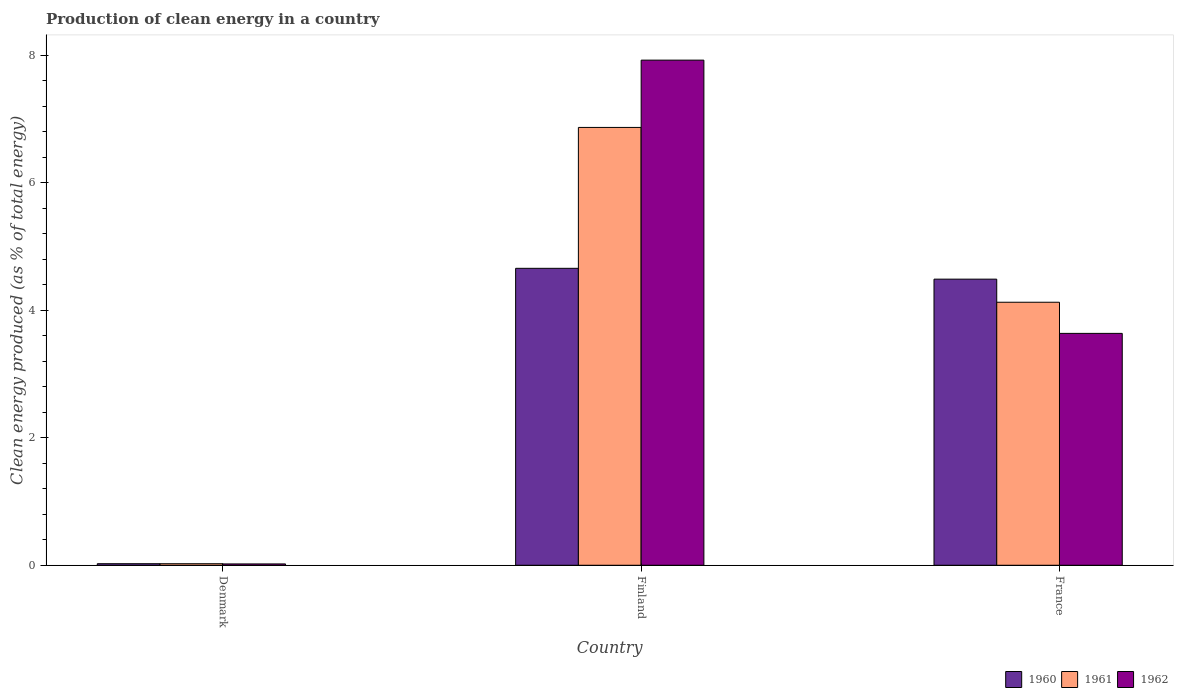Are the number of bars per tick equal to the number of legend labels?
Your answer should be compact. Yes. Are the number of bars on each tick of the X-axis equal?
Your answer should be very brief. Yes. How many bars are there on the 3rd tick from the right?
Offer a very short reply. 3. In how many cases, is the number of bars for a given country not equal to the number of legend labels?
Keep it short and to the point. 0. What is the percentage of clean energy produced in 1960 in France?
Offer a terse response. 4.49. Across all countries, what is the maximum percentage of clean energy produced in 1961?
Ensure brevity in your answer.  6.87. Across all countries, what is the minimum percentage of clean energy produced in 1962?
Ensure brevity in your answer.  0.02. In which country was the percentage of clean energy produced in 1961 maximum?
Offer a terse response. Finland. In which country was the percentage of clean energy produced in 1960 minimum?
Keep it short and to the point. Denmark. What is the total percentage of clean energy produced in 1960 in the graph?
Your response must be concise. 9.17. What is the difference between the percentage of clean energy produced in 1961 in Denmark and that in Finland?
Ensure brevity in your answer.  -6.84. What is the difference between the percentage of clean energy produced in 1962 in France and the percentage of clean energy produced in 1960 in Finland?
Offer a very short reply. -1.02. What is the average percentage of clean energy produced in 1960 per country?
Your answer should be compact. 3.06. What is the difference between the percentage of clean energy produced of/in 1962 and percentage of clean energy produced of/in 1960 in Denmark?
Your response must be concise. -0. In how many countries, is the percentage of clean energy produced in 1962 greater than 6.4 %?
Keep it short and to the point. 1. What is the ratio of the percentage of clean energy produced in 1961 in Denmark to that in France?
Ensure brevity in your answer.  0.01. Is the percentage of clean energy produced in 1961 in Finland less than that in France?
Provide a short and direct response. No. Is the difference between the percentage of clean energy produced in 1962 in Finland and France greater than the difference between the percentage of clean energy produced in 1960 in Finland and France?
Ensure brevity in your answer.  Yes. What is the difference between the highest and the second highest percentage of clean energy produced in 1960?
Your answer should be compact. -4.63. What is the difference between the highest and the lowest percentage of clean energy produced in 1961?
Provide a short and direct response. 6.84. In how many countries, is the percentage of clean energy produced in 1962 greater than the average percentage of clean energy produced in 1962 taken over all countries?
Keep it short and to the point. 1. Is the sum of the percentage of clean energy produced in 1960 in Denmark and France greater than the maximum percentage of clean energy produced in 1961 across all countries?
Offer a terse response. No. What does the 1st bar from the right in Denmark represents?
Your answer should be compact. 1962. Is it the case that in every country, the sum of the percentage of clean energy produced in 1961 and percentage of clean energy produced in 1962 is greater than the percentage of clean energy produced in 1960?
Give a very brief answer. Yes. Are all the bars in the graph horizontal?
Ensure brevity in your answer.  No. Does the graph contain any zero values?
Make the answer very short. No. How many legend labels are there?
Keep it short and to the point. 3. How are the legend labels stacked?
Your response must be concise. Horizontal. What is the title of the graph?
Ensure brevity in your answer.  Production of clean energy in a country. Does "1980" appear as one of the legend labels in the graph?
Provide a short and direct response. No. What is the label or title of the Y-axis?
Your answer should be very brief. Clean energy produced (as % of total energy). What is the Clean energy produced (as % of total energy) of 1960 in Denmark?
Provide a short and direct response. 0.02. What is the Clean energy produced (as % of total energy) of 1961 in Denmark?
Your response must be concise. 0.02. What is the Clean energy produced (as % of total energy) in 1962 in Denmark?
Provide a succinct answer. 0.02. What is the Clean energy produced (as % of total energy) of 1960 in Finland?
Your answer should be compact. 4.66. What is the Clean energy produced (as % of total energy) in 1961 in Finland?
Offer a very short reply. 6.87. What is the Clean energy produced (as % of total energy) in 1962 in Finland?
Ensure brevity in your answer.  7.92. What is the Clean energy produced (as % of total energy) of 1960 in France?
Give a very brief answer. 4.49. What is the Clean energy produced (as % of total energy) in 1961 in France?
Your response must be concise. 4.12. What is the Clean energy produced (as % of total energy) of 1962 in France?
Provide a succinct answer. 3.64. Across all countries, what is the maximum Clean energy produced (as % of total energy) of 1960?
Make the answer very short. 4.66. Across all countries, what is the maximum Clean energy produced (as % of total energy) of 1961?
Keep it short and to the point. 6.87. Across all countries, what is the maximum Clean energy produced (as % of total energy) of 1962?
Offer a terse response. 7.92. Across all countries, what is the minimum Clean energy produced (as % of total energy) of 1960?
Your response must be concise. 0.02. Across all countries, what is the minimum Clean energy produced (as % of total energy) in 1961?
Offer a very short reply. 0.02. Across all countries, what is the minimum Clean energy produced (as % of total energy) of 1962?
Offer a terse response. 0.02. What is the total Clean energy produced (as % of total energy) of 1960 in the graph?
Give a very brief answer. 9.17. What is the total Clean energy produced (as % of total energy) in 1961 in the graph?
Provide a succinct answer. 11.01. What is the total Clean energy produced (as % of total energy) in 1962 in the graph?
Offer a very short reply. 11.58. What is the difference between the Clean energy produced (as % of total energy) of 1960 in Denmark and that in Finland?
Keep it short and to the point. -4.63. What is the difference between the Clean energy produced (as % of total energy) in 1961 in Denmark and that in Finland?
Provide a short and direct response. -6.84. What is the difference between the Clean energy produced (as % of total energy) in 1962 in Denmark and that in Finland?
Provide a short and direct response. -7.9. What is the difference between the Clean energy produced (as % of total energy) of 1960 in Denmark and that in France?
Give a very brief answer. -4.46. What is the difference between the Clean energy produced (as % of total energy) of 1961 in Denmark and that in France?
Provide a succinct answer. -4.1. What is the difference between the Clean energy produced (as % of total energy) in 1962 in Denmark and that in France?
Make the answer very short. -3.62. What is the difference between the Clean energy produced (as % of total energy) in 1960 in Finland and that in France?
Your answer should be compact. 0.17. What is the difference between the Clean energy produced (as % of total energy) in 1961 in Finland and that in France?
Your answer should be compact. 2.74. What is the difference between the Clean energy produced (as % of total energy) of 1962 in Finland and that in France?
Keep it short and to the point. 4.28. What is the difference between the Clean energy produced (as % of total energy) in 1960 in Denmark and the Clean energy produced (as % of total energy) in 1961 in Finland?
Make the answer very short. -6.84. What is the difference between the Clean energy produced (as % of total energy) in 1960 in Denmark and the Clean energy produced (as % of total energy) in 1962 in Finland?
Make the answer very short. -7.9. What is the difference between the Clean energy produced (as % of total energy) in 1961 in Denmark and the Clean energy produced (as % of total energy) in 1962 in Finland?
Your answer should be very brief. -7.9. What is the difference between the Clean energy produced (as % of total energy) of 1960 in Denmark and the Clean energy produced (as % of total energy) of 1961 in France?
Give a very brief answer. -4.1. What is the difference between the Clean energy produced (as % of total energy) of 1960 in Denmark and the Clean energy produced (as % of total energy) of 1962 in France?
Keep it short and to the point. -3.61. What is the difference between the Clean energy produced (as % of total energy) in 1961 in Denmark and the Clean energy produced (as % of total energy) in 1962 in France?
Your answer should be compact. -3.61. What is the difference between the Clean energy produced (as % of total energy) of 1960 in Finland and the Clean energy produced (as % of total energy) of 1961 in France?
Offer a very short reply. 0.53. What is the difference between the Clean energy produced (as % of total energy) of 1960 in Finland and the Clean energy produced (as % of total energy) of 1962 in France?
Make the answer very short. 1.02. What is the difference between the Clean energy produced (as % of total energy) in 1961 in Finland and the Clean energy produced (as % of total energy) in 1962 in France?
Ensure brevity in your answer.  3.23. What is the average Clean energy produced (as % of total energy) in 1960 per country?
Keep it short and to the point. 3.06. What is the average Clean energy produced (as % of total energy) in 1961 per country?
Give a very brief answer. 3.67. What is the average Clean energy produced (as % of total energy) in 1962 per country?
Provide a short and direct response. 3.86. What is the difference between the Clean energy produced (as % of total energy) in 1960 and Clean energy produced (as % of total energy) in 1961 in Denmark?
Your answer should be compact. 0. What is the difference between the Clean energy produced (as % of total energy) of 1960 and Clean energy produced (as % of total energy) of 1962 in Denmark?
Keep it short and to the point. 0. What is the difference between the Clean energy produced (as % of total energy) in 1961 and Clean energy produced (as % of total energy) in 1962 in Denmark?
Keep it short and to the point. 0. What is the difference between the Clean energy produced (as % of total energy) of 1960 and Clean energy produced (as % of total energy) of 1961 in Finland?
Offer a terse response. -2.21. What is the difference between the Clean energy produced (as % of total energy) of 1960 and Clean energy produced (as % of total energy) of 1962 in Finland?
Give a very brief answer. -3.26. What is the difference between the Clean energy produced (as % of total energy) in 1961 and Clean energy produced (as % of total energy) in 1962 in Finland?
Offer a terse response. -1.06. What is the difference between the Clean energy produced (as % of total energy) in 1960 and Clean energy produced (as % of total energy) in 1961 in France?
Keep it short and to the point. 0.36. What is the difference between the Clean energy produced (as % of total energy) in 1960 and Clean energy produced (as % of total energy) in 1962 in France?
Your answer should be very brief. 0.85. What is the difference between the Clean energy produced (as % of total energy) in 1961 and Clean energy produced (as % of total energy) in 1962 in France?
Give a very brief answer. 0.49. What is the ratio of the Clean energy produced (as % of total energy) of 1960 in Denmark to that in Finland?
Ensure brevity in your answer.  0.01. What is the ratio of the Clean energy produced (as % of total energy) of 1961 in Denmark to that in Finland?
Your answer should be compact. 0. What is the ratio of the Clean energy produced (as % of total energy) in 1962 in Denmark to that in Finland?
Provide a short and direct response. 0. What is the ratio of the Clean energy produced (as % of total energy) of 1960 in Denmark to that in France?
Give a very brief answer. 0.01. What is the ratio of the Clean energy produced (as % of total energy) of 1961 in Denmark to that in France?
Your answer should be compact. 0.01. What is the ratio of the Clean energy produced (as % of total energy) in 1962 in Denmark to that in France?
Provide a short and direct response. 0.01. What is the ratio of the Clean energy produced (as % of total energy) in 1960 in Finland to that in France?
Offer a very short reply. 1.04. What is the ratio of the Clean energy produced (as % of total energy) in 1961 in Finland to that in France?
Make the answer very short. 1.66. What is the ratio of the Clean energy produced (as % of total energy) in 1962 in Finland to that in France?
Your response must be concise. 2.18. What is the difference between the highest and the second highest Clean energy produced (as % of total energy) of 1960?
Offer a very short reply. 0.17. What is the difference between the highest and the second highest Clean energy produced (as % of total energy) of 1961?
Make the answer very short. 2.74. What is the difference between the highest and the second highest Clean energy produced (as % of total energy) of 1962?
Keep it short and to the point. 4.28. What is the difference between the highest and the lowest Clean energy produced (as % of total energy) of 1960?
Your response must be concise. 4.63. What is the difference between the highest and the lowest Clean energy produced (as % of total energy) of 1961?
Make the answer very short. 6.84. What is the difference between the highest and the lowest Clean energy produced (as % of total energy) of 1962?
Give a very brief answer. 7.9. 